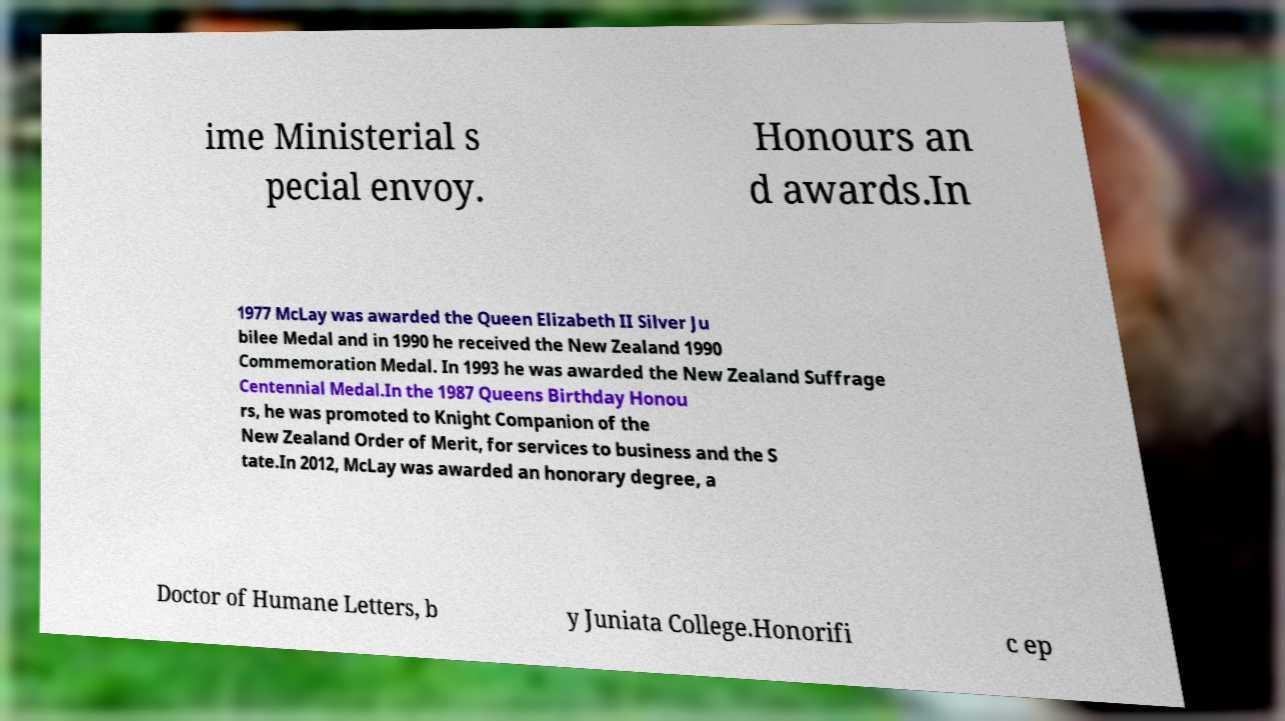Could you assist in decoding the text presented in this image and type it out clearly? ime Ministerial s pecial envoy. Honours an d awards.In 1977 McLay was awarded the Queen Elizabeth II Silver Ju bilee Medal and in 1990 he received the New Zealand 1990 Commemoration Medal. In 1993 he was awarded the New Zealand Suffrage Centennial Medal.In the 1987 Queens Birthday Honou rs, he was promoted to Knight Companion of the New Zealand Order of Merit, for services to business and the S tate.In 2012, McLay was awarded an honorary degree, a Doctor of Humane Letters, b y Juniata College.Honorifi c ep 